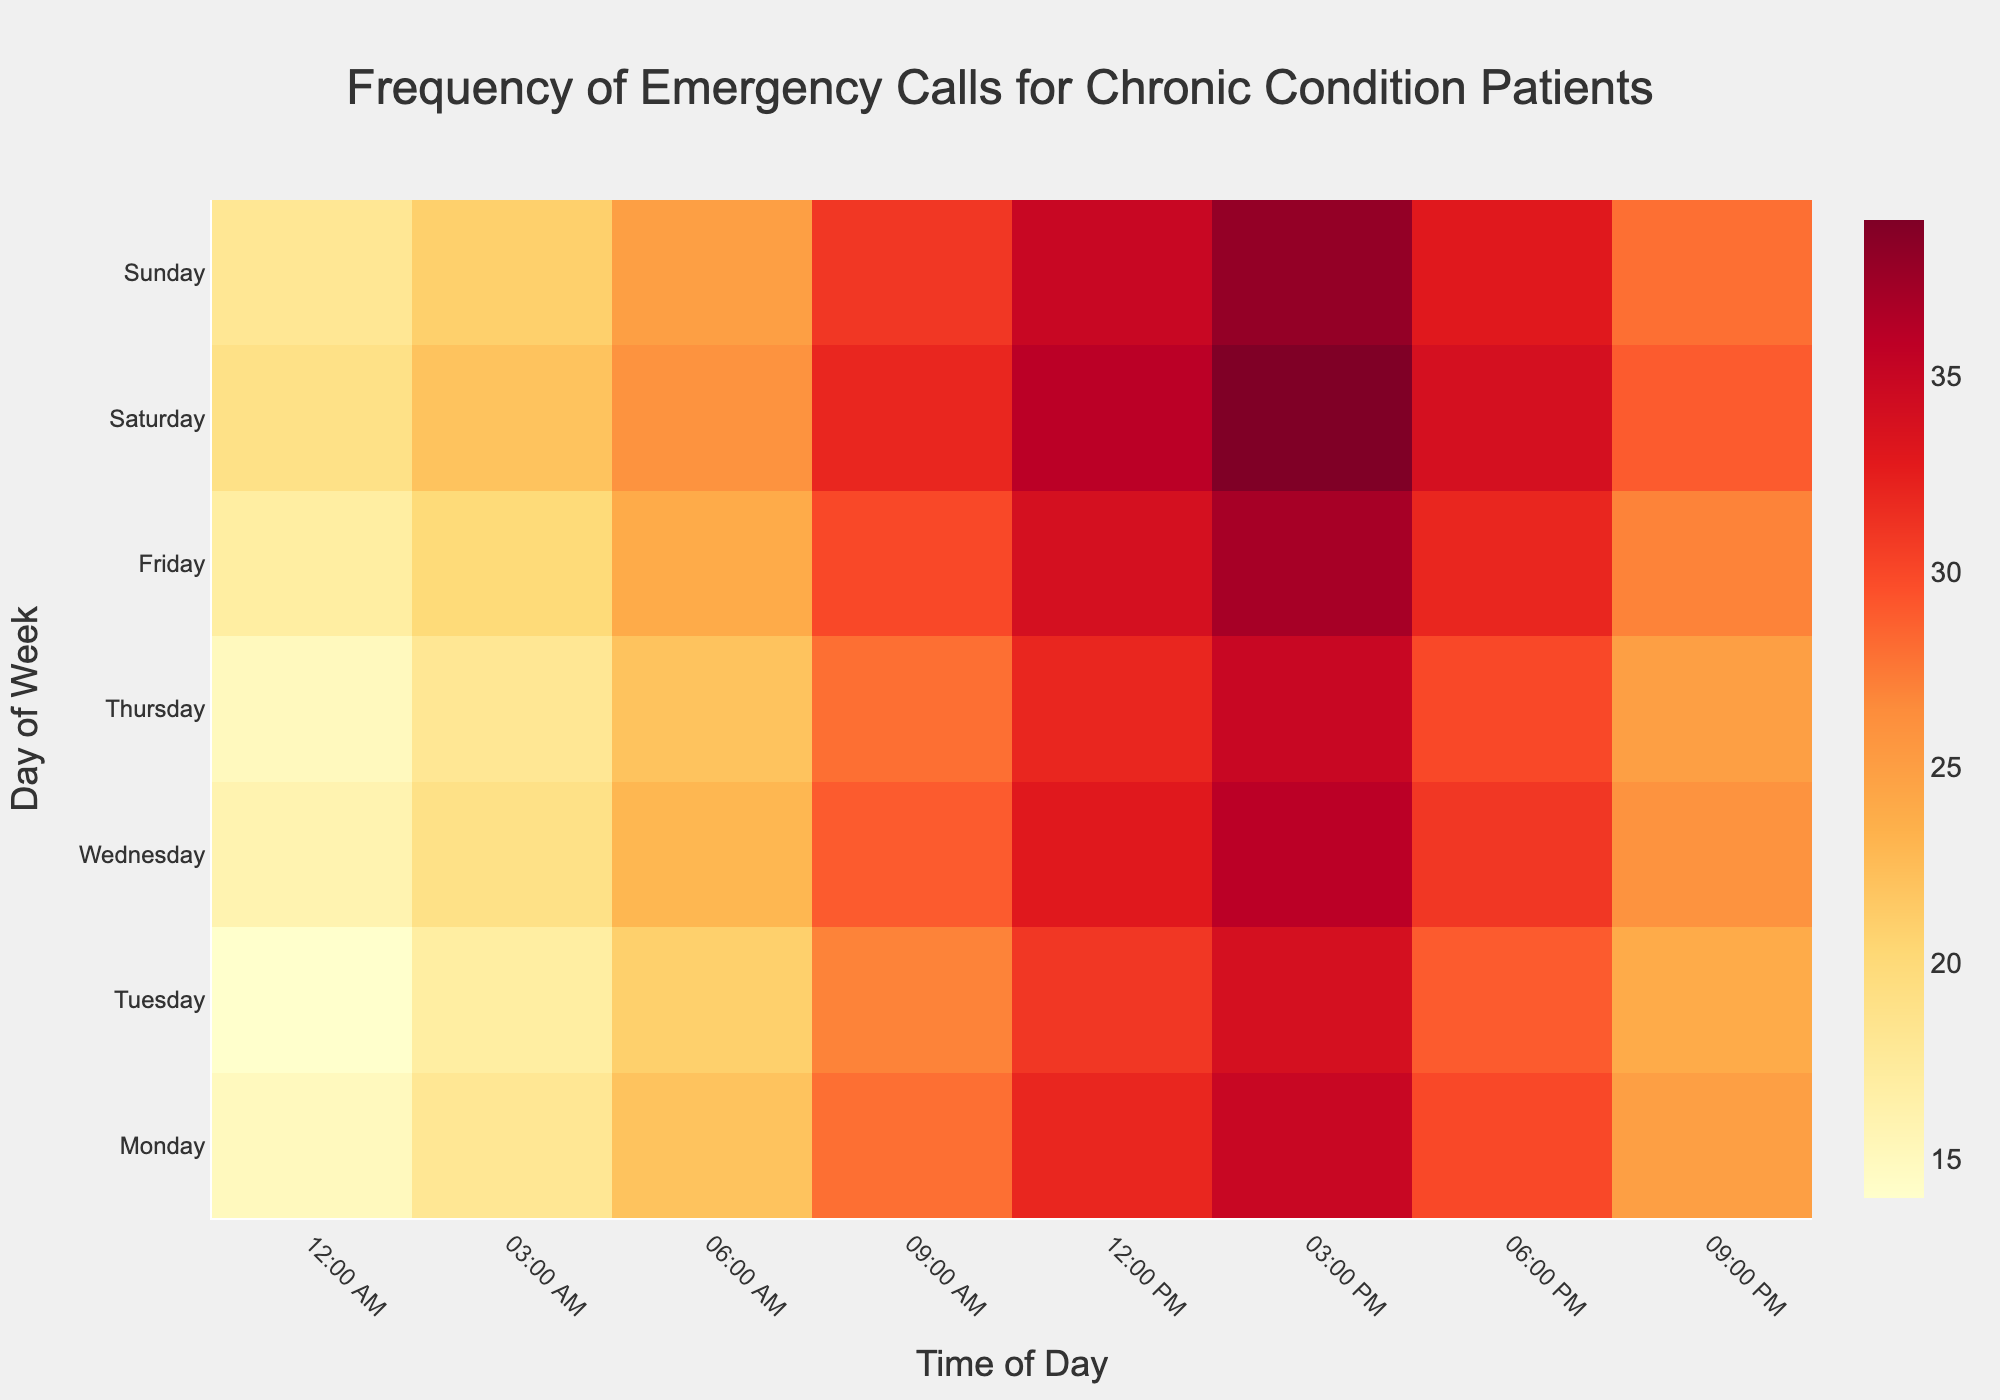When are emergency calls most frequent throughout the week? The color intensity on the heatmap shows that the highest frequency of calls occurs around 3:00 PM to 6:00 PM, particularly on the weekends (Saturday and Sunday)
Answer: 3:00 PM to 6:00 PM on weekends Which day has the highest number of emergency calls at 6:00 AM? By examining the color intensity at 6:00 AM across different days, Saturday has a slightly darker shade than other days, indicating the highest call frequency
Answer: Saturday How do the number of emergency calls at 09:00 AM on Monday compare to those on Friday at the same time? On Monday at 9:00 AM, there is a lighter color compared to Friday. This means the number of calls on Monday is less than on Friday at 9:00 AM. Specifically, Monday has 28 calls and Friday has 30 calls
Answer: Less on Monday What is the trend of emergency calls from Midnight (00:00) to 9:00 AM across all days? The intensity of colors increases from Midnight towards 9:00 AM each day. This suggests there is a rising trend in the number of emergency calls from Midnight to 9:00 AM
Answer: Increasing Which time slot has the lowest number of emergency calls for chronic condition patients during the week? The lightest color cells in the heatmap are found at Midnight (00:00) across all days, suggesting the least number of calls is during this time slot
Answer: 00:00 How does the emergency call frequency at 3:00 PM on Wednesday compare to that at 3:00 AM on the same day? The color at 3:00 PM is much more intense and dark compared to 3:00 AM on Wednesday, indicating more calls at 3:00 PM (36 calls) versus at 3:00 AM (19 calls)
Answer: More at 3:00 PM What's the total number of emergency calls made at 3:00 AM throughout the week? Sum the number of calls at 3:00 AM for each day: Monday (18), Tuesday (17), Wednesday (19), Thursday (18), Friday (20), Saturday (22), and Sunday (21). So, 18 + 17 + 19 + 18 + 20 + 22 + 21 = 135
Answer: 135 At what times during Friday are the emergency calls most and least frequent? The darkest cell (most frequent) on Friday is at 3:00 PM, and the lightest cell (least frequent) is at Midnight (00:00)
Answer: 3:00 PM (most), Midnight (00:00) (least) Which time of day shows the most consistent emergency call frequency across all days? By observing the color consistency across different days, the period around 3:00 PM shows a similar intense color indicating a consistently high call frequency regardless of the day
Answer: 3:00 PM 